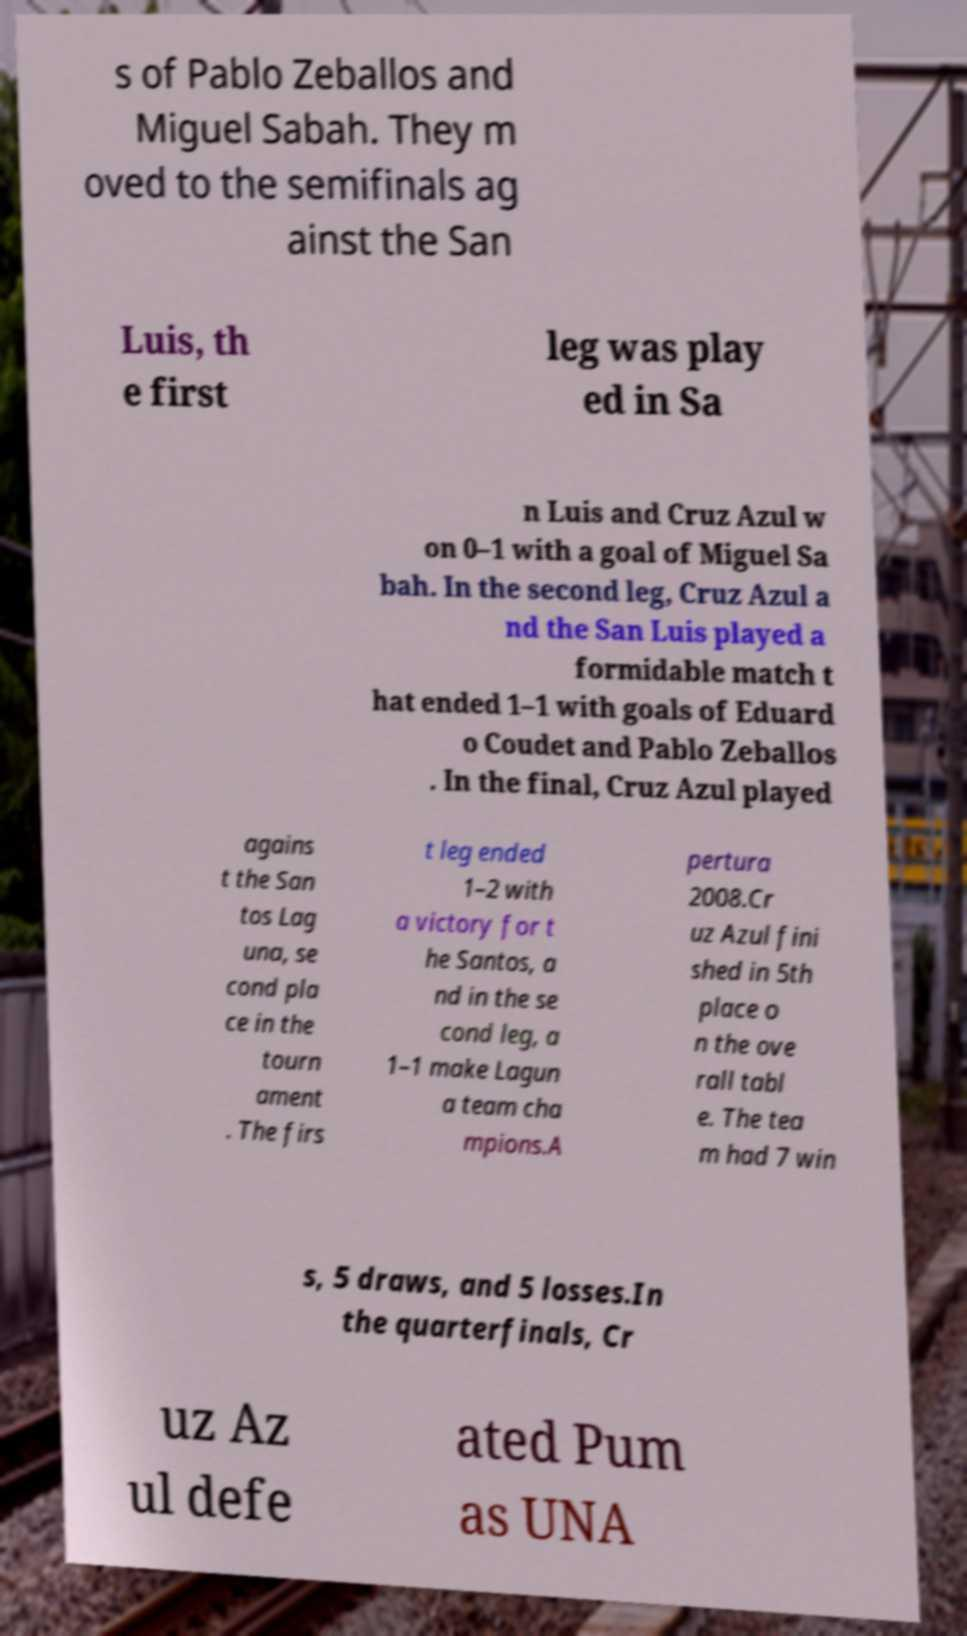There's text embedded in this image that I need extracted. Can you transcribe it verbatim? s of Pablo Zeballos and Miguel Sabah. They m oved to the semifinals ag ainst the San Luis, th e first leg was play ed in Sa n Luis and Cruz Azul w on 0–1 with a goal of Miguel Sa bah. In the second leg, Cruz Azul a nd the San Luis played a formidable match t hat ended 1–1 with goals of Eduard o Coudet and Pablo Zeballos . In the final, Cruz Azul played agains t the San tos Lag una, se cond pla ce in the tourn ament . The firs t leg ended 1–2 with a victory for t he Santos, a nd in the se cond leg, a 1–1 make Lagun a team cha mpions.A pertura 2008.Cr uz Azul fini shed in 5th place o n the ove rall tabl e. The tea m had 7 win s, 5 draws, and 5 losses.In the quarterfinals, Cr uz Az ul defe ated Pum as UNA 